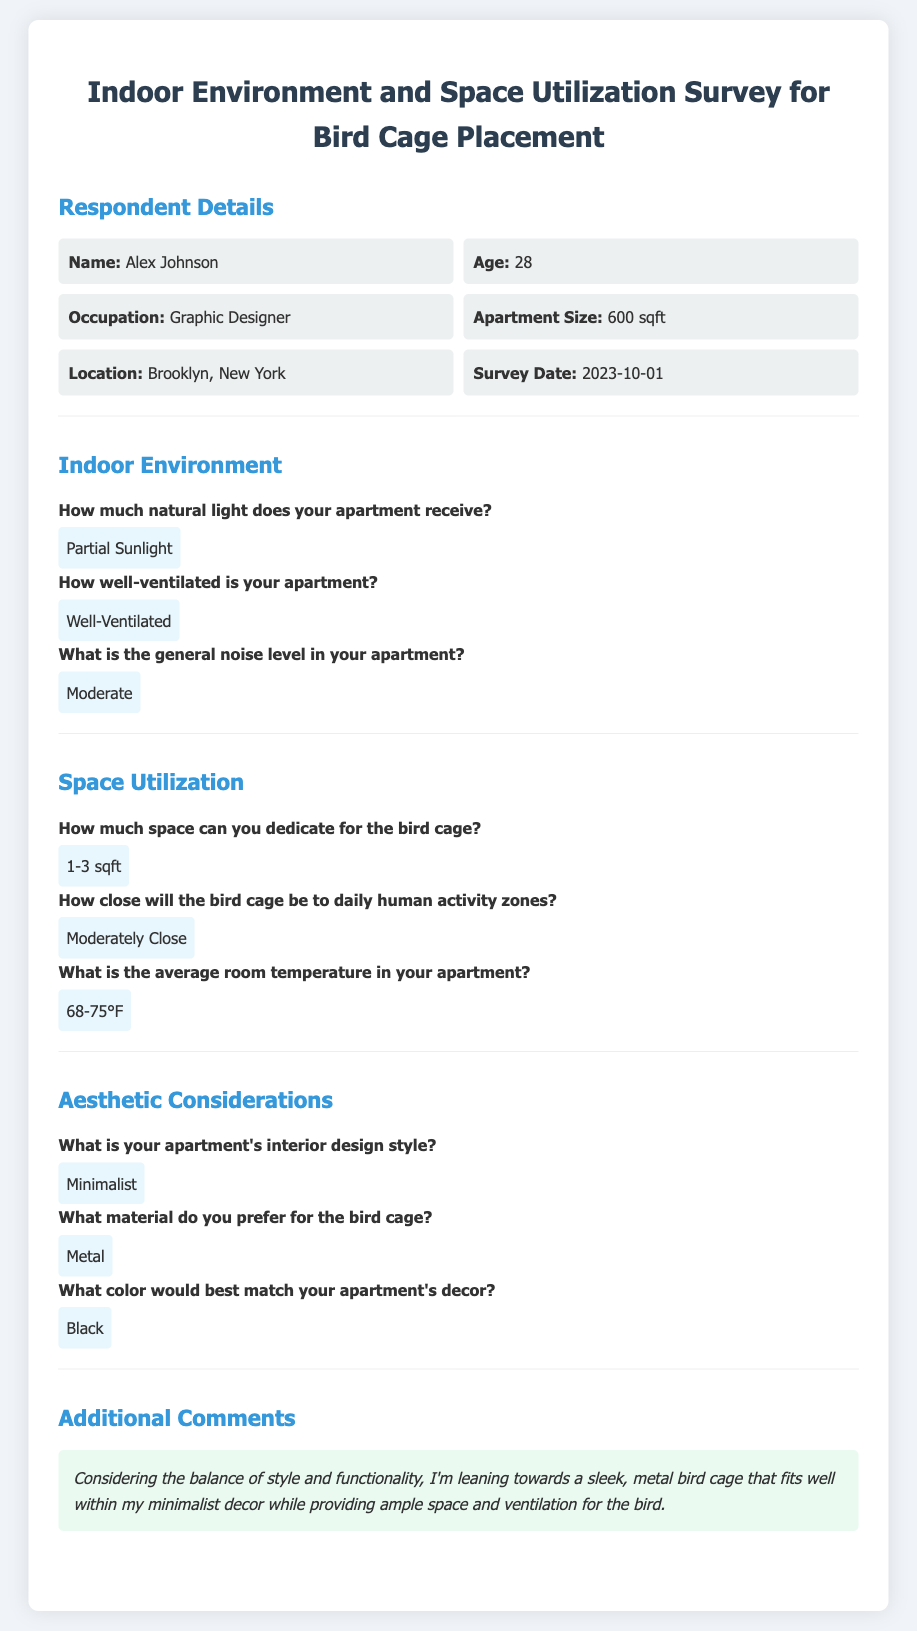What is the name of the respondent? The name of the respondent is listed in the document under Respondent Details.
Answer: Alex Johnson What is the age of the respondent? The age is provided right after the respondent's name in the document.
Answer: 28 How much space can be dedicated for the bird cage? The space allocation for the bird cage is specified in the Space Utilization section of the document.
Answer: 1-3 sqft What is the average room temperature? The average room temperature is found in the Space Utilization section.
Answer: 68-75°F What material does the respondent prefer for the bird cage? The preferred material for the bird cage is stated in the Aesthetic Considerations section.
Answer: Metal What is the general noise level in the apartment? This information can be found in the Indoor Environment section of the document.
Answer: Moderate How close will the bird cage be to daily human activity zones? This detail is provided in the Space Utilization section.
Answer: Moderately Close What is the respondent's apartment's interior design style? The design style is mentioned in the Aesthetic Considerations section.
Answer: Minimalist What color would best match the apartment's decor? The preferred color is specified in the Aesthetic Considerations section of the document.
Answer: Black 